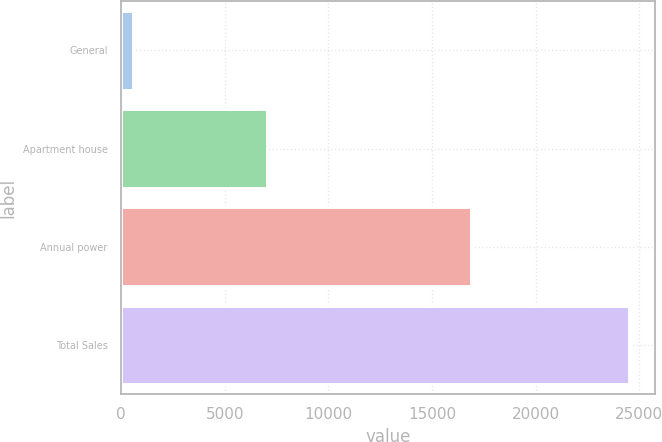Convert chart. <chart><loc_0><loc_0><loc_500><loc_500><bar_chart><fcel>General<fcel>Apartment house<fcel>Annual power<fcel>Total Sales<nl><fcel>600<fcel>7022<fcel>16897<fcel>24519<nl></chart> 